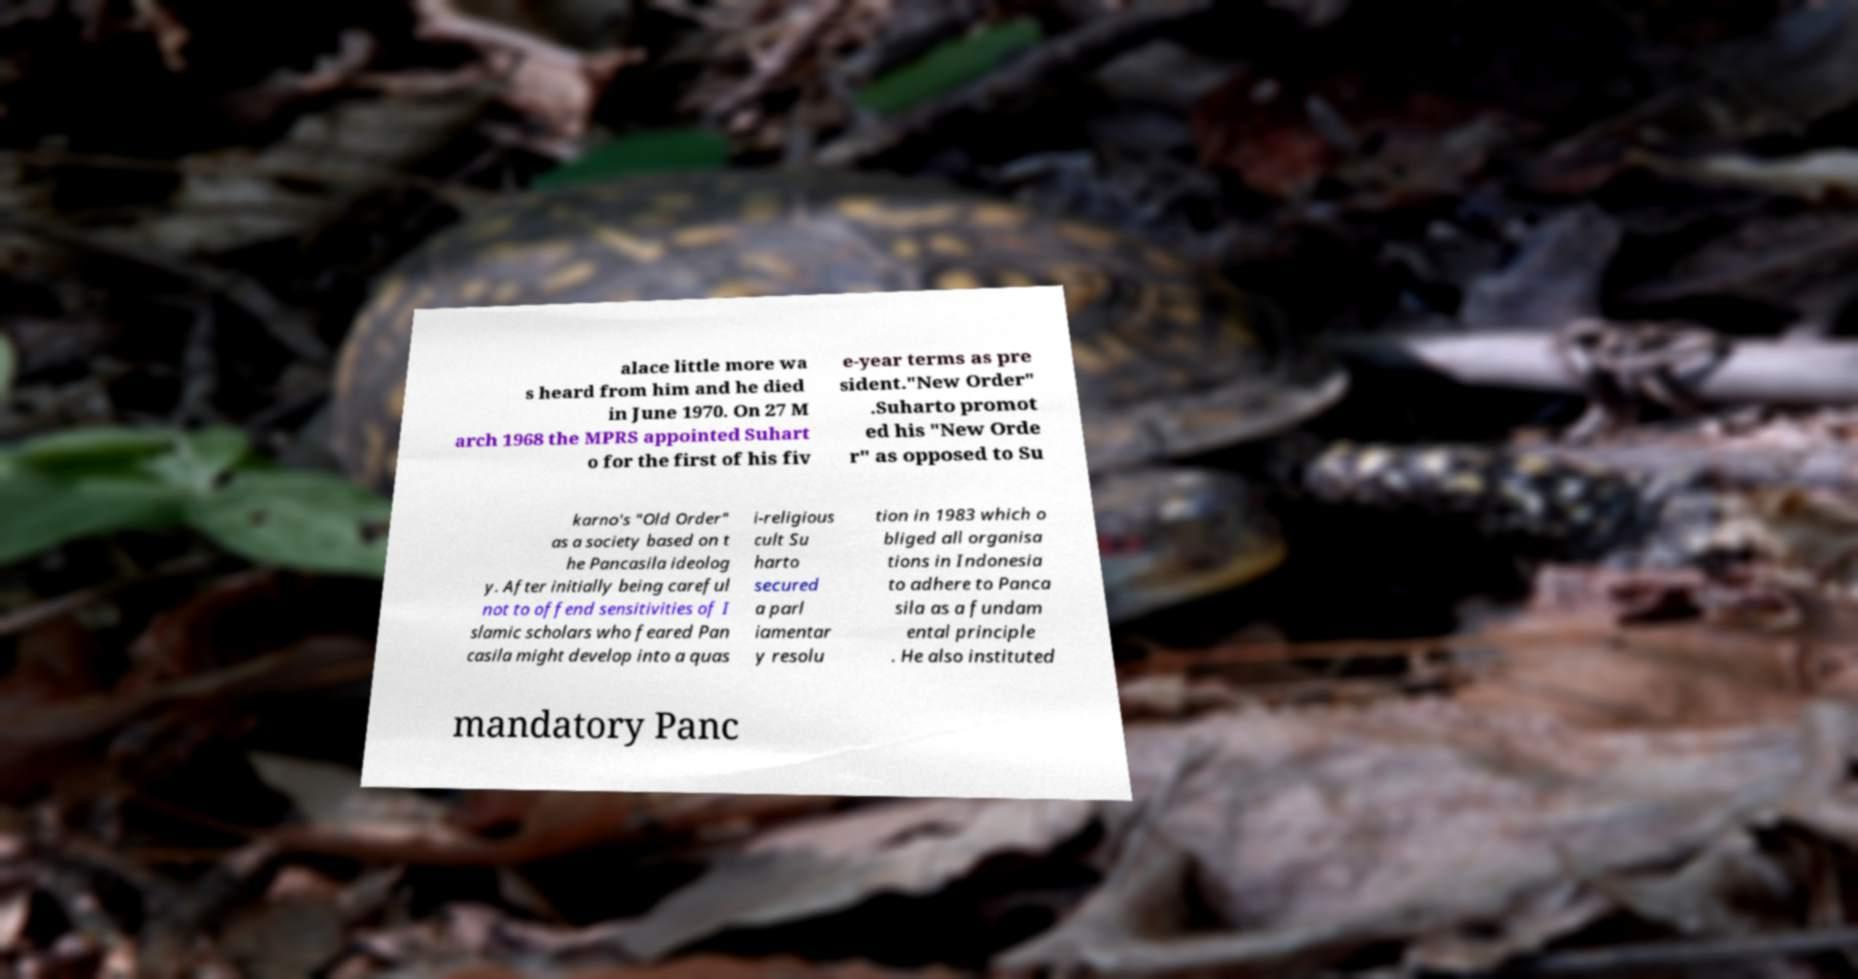Can you accurately transcribe the text from the provided image for me? alace little more wa s heard from him and he died in June 1970. On 27 M arch 1968 the MPRS appointed Suhart o for the first of his fiv e-year terms as pre sident."New Order" .Suharto promot ed his "New Orde r" as opposed to Su karno's "Old Order" as a society based on t he Pancasila ideolog y. After initially being careful not to offend sensitivities of I slamic scholars who feared Pan casila might develop into a quas i-religious cult Su harto secured a parl iamentar y resolu tion in 1983 which o bliged all organisa tions in Indonesia to adhere to Panca sila as a fundam ental principle . He also instituted mandatory Panc 